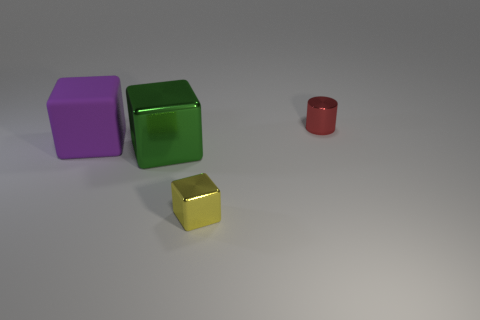Add 1 yellow shiny blocks. How many objects exist? 5 Subtract all cubes. How many objects are left? 1 Add 3 big rubber cubes. How many big rubber cubes exist? 4 Subtract 1 green cubes. How many objects are left? 3 Subtract all matte blocks. Subtract all red matte cylinders. How many objects are left? 3 Add 2 large purple things. How many large purple things are left? 3 